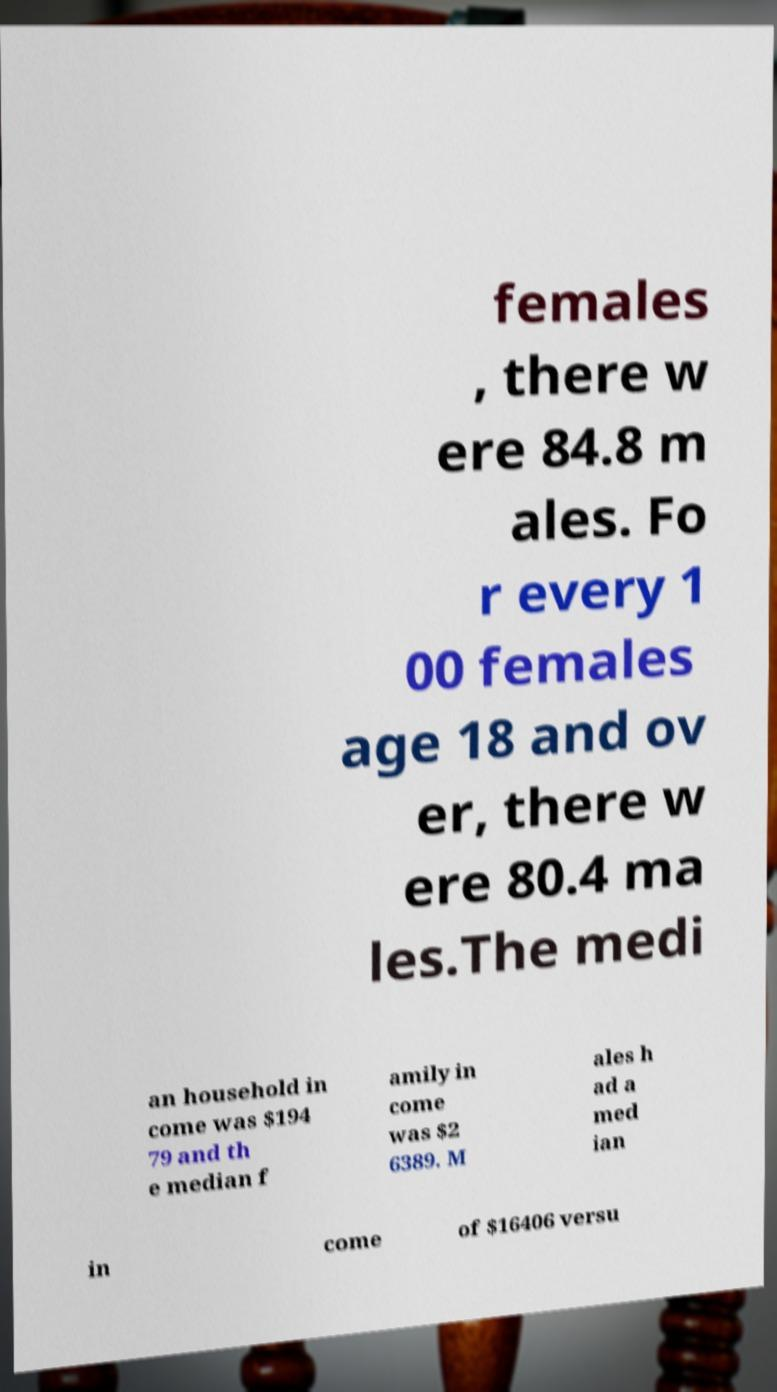Can you accurately transcribe the text from the provided image for me? females , there w ere 84.8 m ales. Fo r every 1 00 females age 18 and ov er, there w ere 80.4 ma les.The medi an household in come was $194 79 and th e median f amily in come was $2 6389. M ales h ad a med ian in come of $16406 versu 